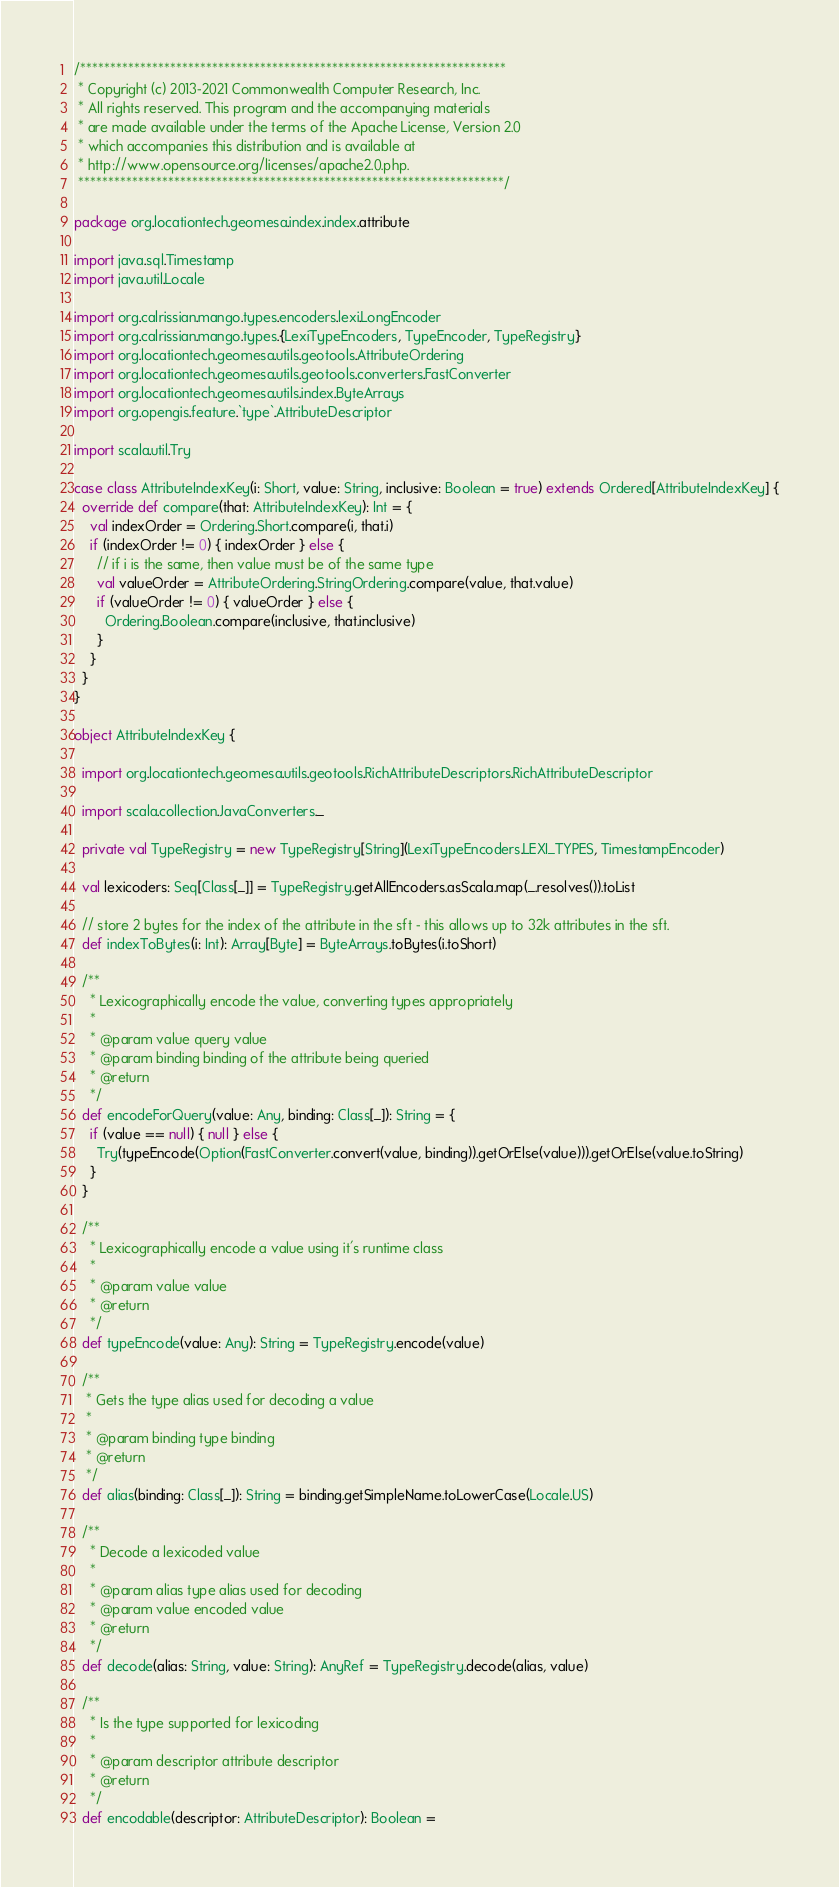<code> <loc_0><loc_0><loc_500><loc_500><_Scala_>/***********************************************************************
 * Copyright (c) 2013-2021 Commonwealth Computer Research, Inc.
 * All rights reserved. This program and the accompanying materials
 * are made available under the terms of the Apache License, Version 2.0
 * which accompanies this distribution and is available at
 * http://www.opensource.org/licenses/apache2.0.php.
 ***********************************************************************/

package org.locationtech.geomesa.index.index.attribute

import java.sql.Timestamp
import java.util.Locale

import org.calrissian.mango.types.encoders.lexi.LongEncoder
import org.calrissian.mango.types.{LexiTypeEncoders, TypeEncoder, TypeRegistry}
import org.locationtech.geomesa.utils.geotools.AttributeOrdering
import org.locationtech.geomesa.utils.geotools.converters.FastConverter
import org.locationtech.geomesa.utils.index.ByteArrays
import org.opengis.feature.`type`.AttributeDescriptor

import scala.util.Try

case class AttributeIndexKey(i: Short, value: String, inclusive: Boolean = true) extends Ordered[AttributeIndexKey] {
  override def compare(that: AttributeIndexKey): Int = {
    val indexOrder = Ordering.Short.compare(i, that.i)
    if (indexOrder != 0) { indexOrder } else {
      // if i is the same, then value must be of the same type
      val valueOrder = AttributeOrdering.StringOrdering.compare(value, that.value)
      if (valueOrder != 0) { valueOrder } else {
        Ordering.Boolean.compare(inclusive, that.inclusive)
      }
    }
  }
}

object AttributeIndexKey {

  import org.locationtech.geomesa.utils.geotools.RichAttributeDescriptors.RichAttributeDescriptor

  import scala.collection.JavaConverters._

  private val TypeRegistry = new TypeRegistry[String](LexiTypeEncoders.LEXI_TYPES, TimestampEncoder)

  val lexicoders: Seq[Class[_]] = TypeRegistry.getAllEncoders.asScala.map(_.resolves()).toList

  // store 2 bytes for the index of the attribute in the sft - this allows up to 32k attributes in the sft.
  def indexToBytes(i: Int): Array[Byte] = ByteArrays.toBytes(i.toShort)

  /**
    * Lexicographically encode the value, converting types appropriately
    *
    * @param value query value
    * @param binding binding of the attribute being queried
    * @return
    */
  def encodeForQuery(value: Any, binding: Class[_]): String = {
    if (value == null) { null } else {
      Try(typeEncode(Option(FastConverter.convert(value, binding)).getOrElse(value))).getOrElse(value.toString)
    }
  }

  /**
    * Lexicographically encode a value using it's runtime class
    *
    * @param value value
    * @return
    */
  def typeEncode(value: Any): String = TypeRegistry.encode(value)

  /**
   * Gets the type alias used for decoding a value
   *
   * @param binding type binding
   * @return
   */
  def alias(binding: Class[_]): String = binding.getSimpleName.toLowerCase(Locale.US)

  /**
    * Decode a lexicoded value
    *
    * @param alias type alias used for decoding
    * @param value encoded value
    * @return
    */
  def decode(alias: String, value: String): AnyRef = TypeRegistry.decode(alias, value)

  /**
    * Is the type supported for lexicoding
    *
    * @param descriptor attribute descriptor
    * @return
    */
  def encodable(descriptor: AttributeDescriptor): Boolean =</code> 